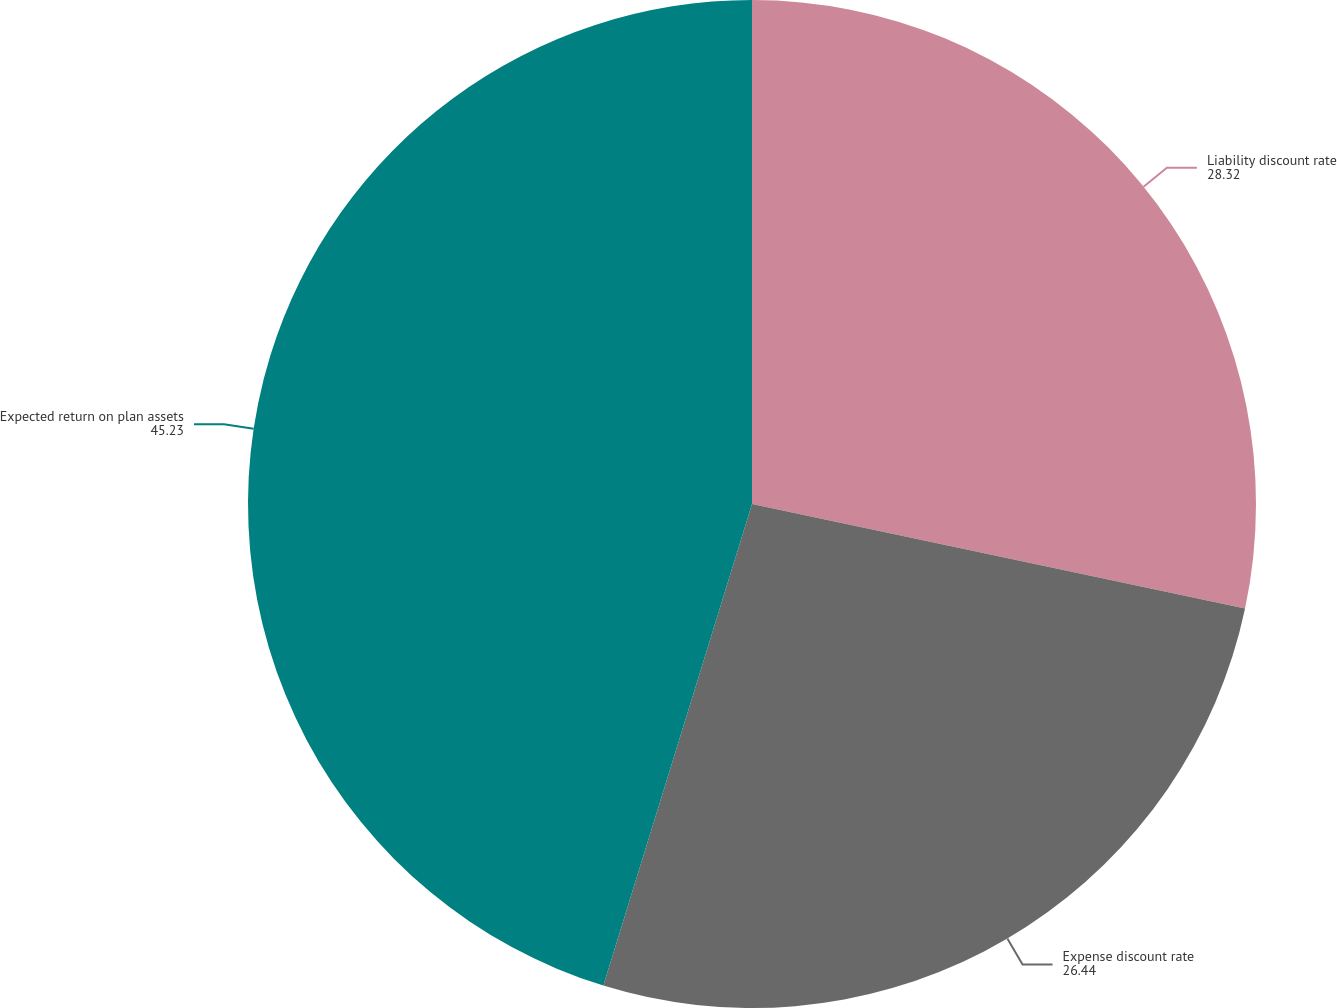Convert chart. <chart><loc_0><loc_0><loc_500><loc_500><pie_chart><fcel>Liability discount rate<fcel>Expense discount rate<fcel>Expected return on plan assets<nl><fcel>28.32%<fcel>26.44%<fcel>45.23%<nl></chart> 